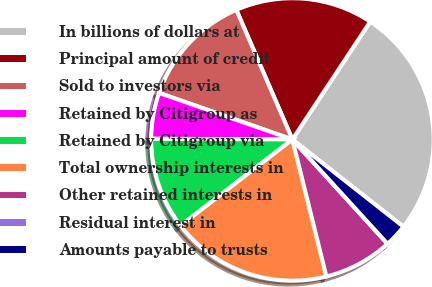<chart> <loc_0><loc_0><loc_500><loc_500><pie_chart><fcel>In billions of dollars at<fcel>Principal amount of credit<fcel>Sold to investors via<fcel>Retained by Citigroup as<fcel>Retained by Citigroup via<fcel>Total ownership interests in<fcel>Other retained interests in<fcel>Residual interest in<fcel>Amounts payable to trusts<nl><fcel>26.31%<fcel>15.79%<fcel>13.16%<fcel>5.27%<fcel>10.53%<fcel>18.42%<fcel>7.9%<fcel>0.0%<fcel>2.63%<nl></chart> 